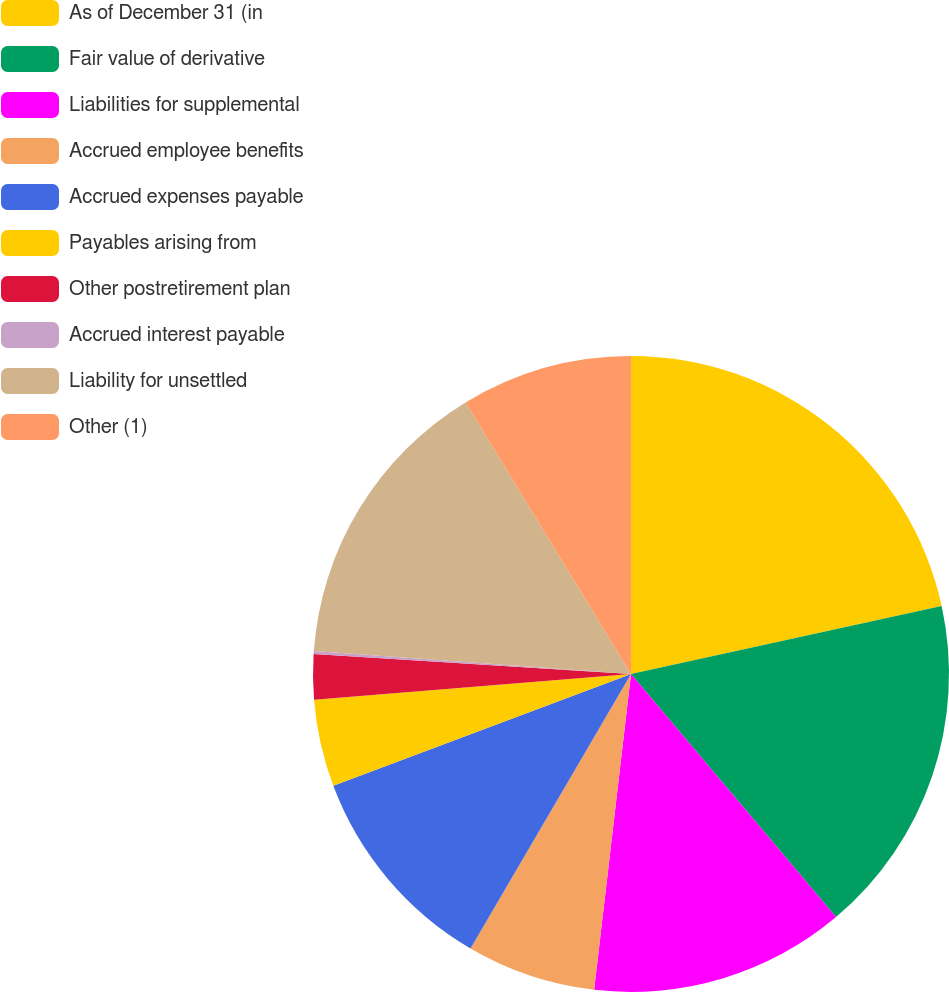Convert chart. <chart><loc_0><loc_0><loc_500><loc_500><pie_chart><fcel>As of December 31 (in<fcel>Fair value of derivative<fcel>Liabilities for supplemental<fcel>Accrued employee benefits<fcel>Accrued expenses payable<fcel>Payables arising from<fcel>Other postretirement plan<fcel>Accrued interest payable<fcel>Liability for unsettled<fcel>Other (1)<nl><fcel>21.57%<fcel>17.28%<fcel>13.0%<fcel>6.57%<fcel>10.86%<fcel>4.43%<fcel>2.29%<fcel>0.15%<fcel>15.14%<fcel>8.71%<nl></chart> 